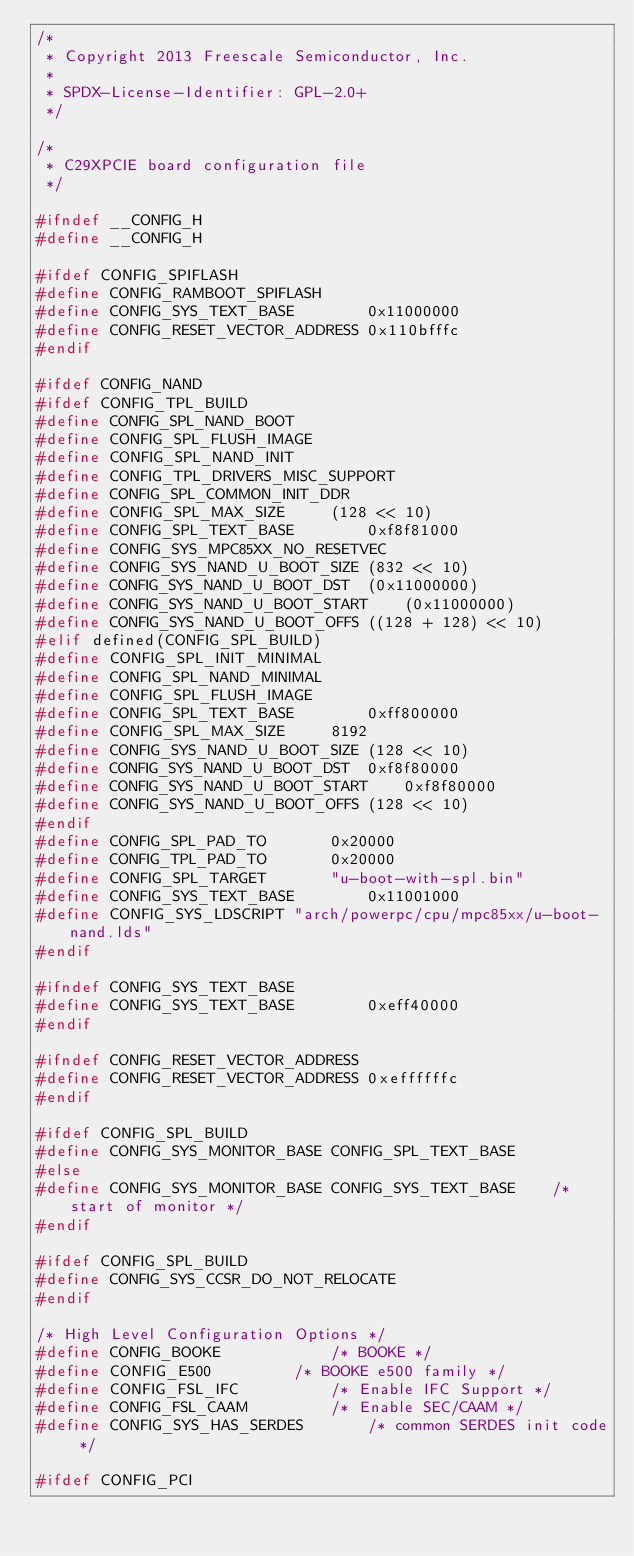<code> <loc_0><loc_0><loc_500><loc_500><_C_>/*
 * Copyright 2013 Freescale Semiconductor, Inc.
 *
 * SPDX-License-Identifier:	GPL-2.0+
 */

/*
 * C29XPCIE board configuration file
 */

#ifndef __CONFIG_H
#define __CONFIG_H

#ifdef CONFIG_SPIFLASH
#define CONFIG_RAMBOOT_SPIFLASH
#define CONFIG_SYS_TEXT_BASE		0x11000000
#define CONFIG_RESET_VECTOR_ADDRESS	0x110bfffc
#endif

#ifdef CONFIG_NAND
#ifdef CONFIG_TPL_BUILD
#define CONFIG_SPL_NAND_BOOT
#define CONFIG_SPL_FLUSH_IMAGE
#define CONFIG_SPL_NAND_INIT
#define CONFIG_TPL_DRIVERS_MISC_SUPPORT
#define CONFIG_SPL_COMMON_INIT_DDR
#define CONFIG_SPL_MAX_SIZE		(128 << 10)
#define CONFIG_SPL_TEXT_BASE		0xf8f81000
#define CONFIG_SYS_MPC85XX_NO_RESETVEC
#define CONFIG_SYS_NAND_U_BOOT_SIZE	(832 << 10)
#define CONFIG_SYS_NAND_U_BOOT_DST	(0x11000000)
#define CONFIG_SYS_NAND_U_BOOT_START	(0x11000000)
#define CONFIG_SYS_NAND_U_BOOT_OFFS	((128 + 128) << 10)
#elif defined(CONFIG_SPL_BUILD)
#define CONFIG_SPL_INIT_MINIMAL
#define CONFIG_SPL_NAND_MINIMAL
#define CONFIG_SPL_FLUSH_IMAGE
#define CONFIG_SPL_TEXT_BASE		0xff800000
#define CONFIG_SPL_MAX_SIZE		8192
#define CONFIG_SYS_NAND_U_BOOT_SIZE	(128 << 10)
#define CONFIG_SYS_NAND_U_BOOT_DST	0xf8f80000
#define CONFIG_SYS_NAND_U_BOOT_START	0xf8f80000
#define CONFIG_SYS_NAND_U_BOOT_OFFS	(128 << 10)
#endif
#define CONFIG_SPL_PAD_TO		0x20000
#define CONFIG_TPL_PAD_TO		0x20000
#define CONFIG_SPL_TARGET		"u-boot-with-spl.bin"
#define CONFIG_SYS_TEXT_BASE		0x11001000
#define CONFIG_SYS_LDSCRIPT	"arch/powerpc/cpu/mpc85xx/u-boot-nand.lds"
#endif

#ifndef CONFIG_SYS_TEXT_BASE
#define CONFIG_SYS_TEXT_BASE		0xeff40000
#endif

#ifndef CONFIG_RESET_VECTOR_ADDRESS
#define CONFIG_RESET_VECTOR_ADDRESS	0xeffffffc
#endif

#ifdef CONFIG_SPL_BUILD
#define CONFIG_SYS_MONITOR_BASE	CONFIG_SPL_TEXT_BASE
#else
#define CONFIG_SYS_MONITOR_BASE	CONFIG_SYS_TEXT_BASE	/* start of monitor */
#endif

#ifdef CONFIG_SPL_BUILD
#define CONFIG_SYS_CCSR_DO_NOT_RELOCATE
#endif

/* High Level Configuration Options */
#define CONFIG_BOOKE			/* BOOKE */
#define CONFIG_E500			/* BOOKE e500 family */
#define CONFIG_FSL_IFC			/* Enable IFC Support */
#define CONFIG_FSL_CAAM			/* Enable SEC/CAAM */
#define CONFIG_SYS_HAS_SERDES		/* common SERDES init code */

#ifdef CONFIG_PCI</code> 